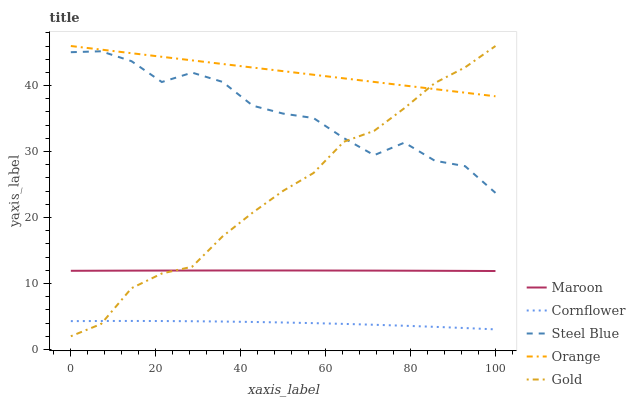Does Cornflower have the minimum area under the curve?
Answer yes or no. Yes. Does Orange have the maximum area under the curve?
Answer yes or no. Yes. Does Gold have the minimum area under the curve?
Answer yes or no. No. Does Gold have the maximum area under the curve?
Answer yes or no. No. Is Orange the smoothest?
Answer yes or no. Yes. Is Steel Blue the roughest?
Answer yes or no. Yes. Is Cornflower the smoothest?
Answer yes or no. No. Is Cornflower the roughest?
Answer yes or no. No. Does Gold have the lowest value?
Answer yes or no. Yes. Does Cornflower have the lowest value?
Answer yes or no. No. Does Gold have the highest value?
Answer yes or no. Yes. Does Cornflower have the highest value?
Answer yes or no. No. Is Cornflower less than Steel Blue?
Answer yes or no. Yes. Is Steel Blue greater than Maroon?
Answer yes or no. Yes. Does Orange intersect Gold?
Answer yes or no. Yes. Is Orange less than Gold?
Answer yes or no. No. Is Orange greater than Gold?
Answer yes or no. No. Does Cornflower intersect Steel Blue?
Answer yes or no. No. 